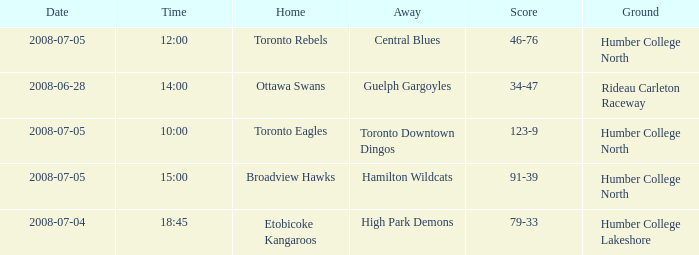What is the Score with a Date that is 2008-06-28? 34-47. 